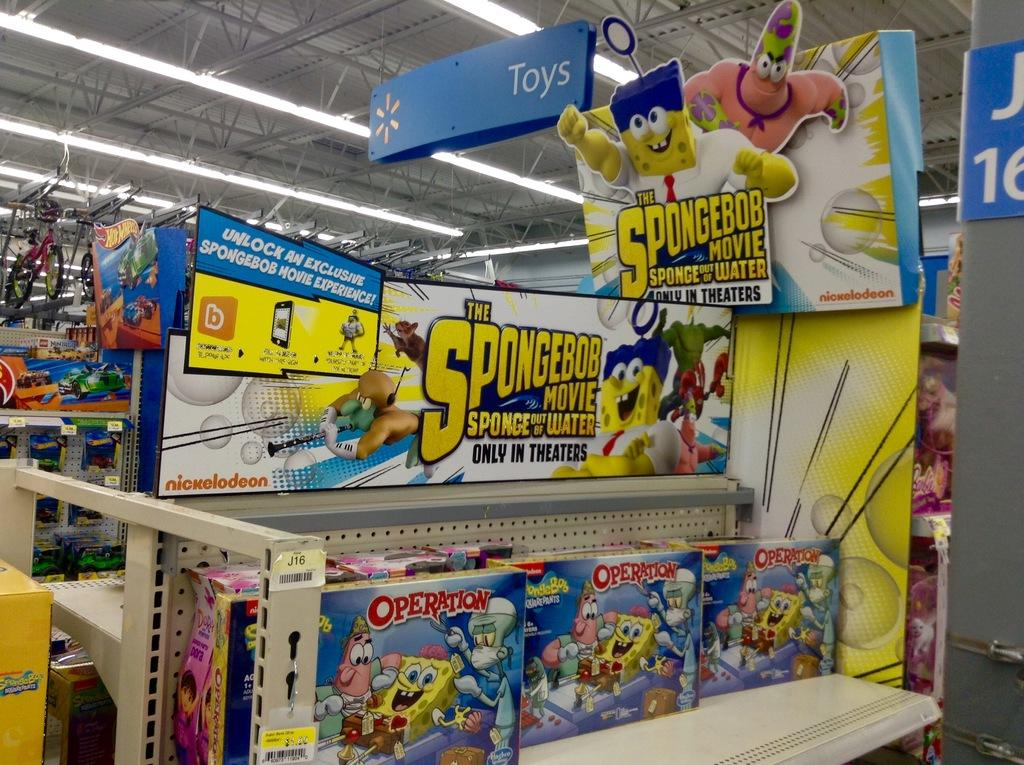Provide a one-sentence caption for the provided image. A Spongebob sign sits above a children's area with toys and movies. 